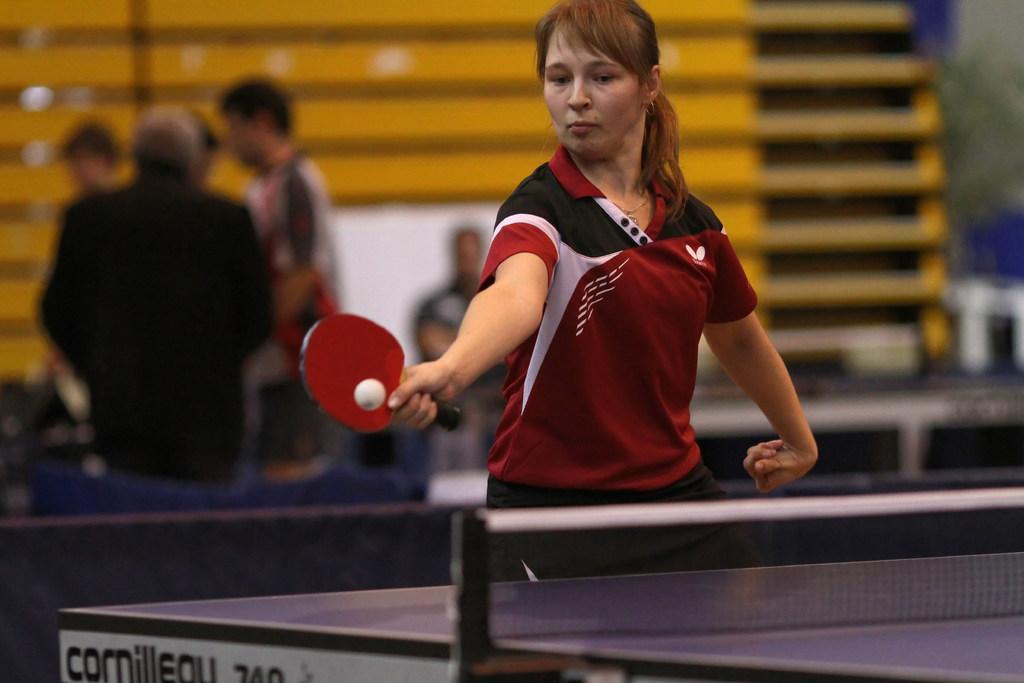Could you give a brief overview of what you see in this image? A lady wearing a red t shirt is playing table tennis. She is holding a bat and a ball is there. In front of her there is a tennis table. In the background there are some person and a yellow wall is there. 